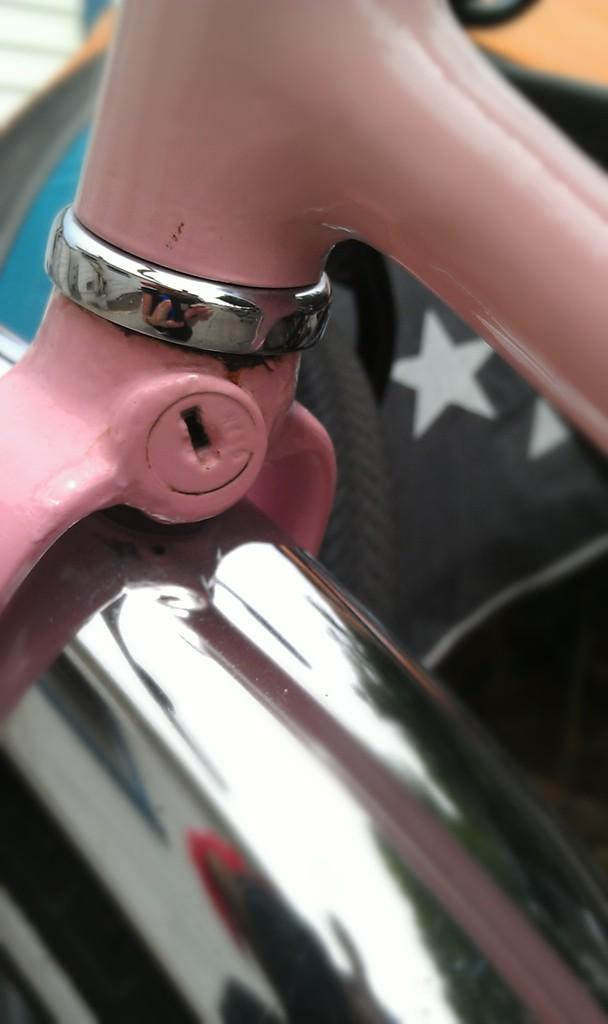What type of objects can be seen in the image? There are metal objects in the image. Can you describe a specific feature of the metal objects? There is a key panel among the metal objects in the image. How does the earthquake affect the objects in the image? There is no earthquake present in the image, so its effects cannot be observed. 